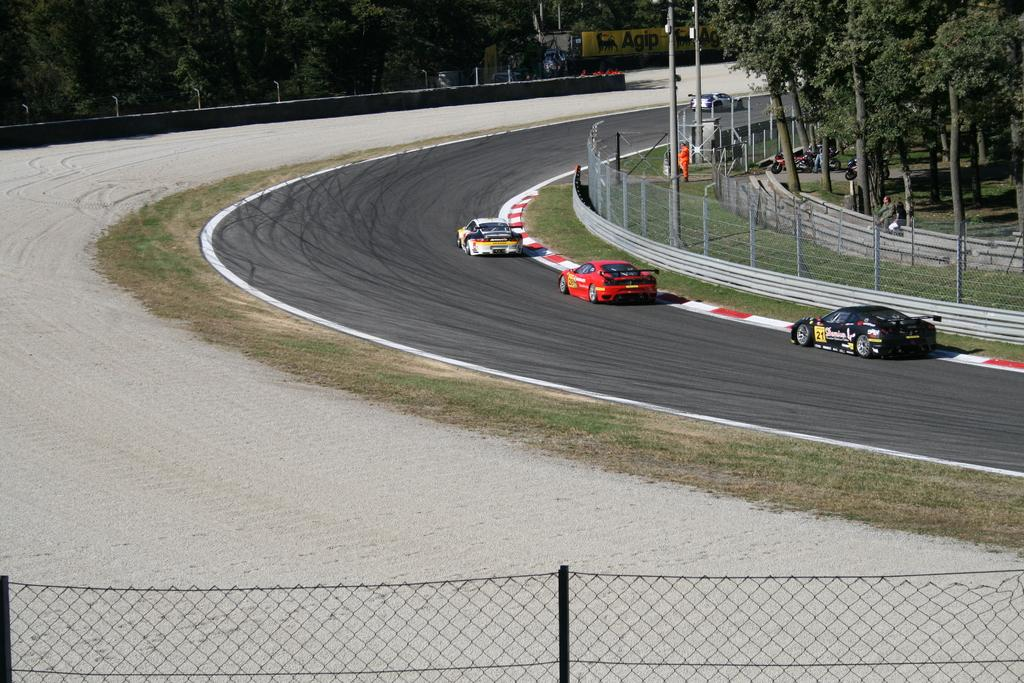What is the main feature of the image? There is a road in the image. What is happening on the road? There are vehicles on the road. What type of vegetation can be seen in the image? There is grass and trees visible in the image. What is in the background of the image? There is a wall in the background of the image. What is in the foreground of the image? There is fencing in the foreground of the image. What type of quince is being used to create a straw in the image? There is no quince or straw present in the image. What action are the vehicles performing in the image? The vehicles are simply visible on the road, and no specific action can be determined from the image. 